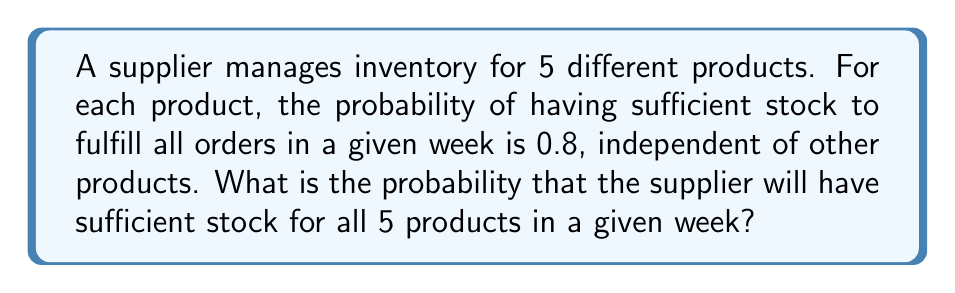Could you help me with this problem? Let's approach this step-by-step:

1) For each product, the probability of having sufficient stock is 0.8.

2) We need to find the probability of having sufficient stock for all 5 products simultaneously.

3) Since the stock sufficiency of each product is independent, we can use the multiplication rule of probability.

4) The probability of all independent events occurring together is the product of their individual probabilities.

5) Let's define the event:
   $A$ = Having sufficient stock for all 5 products

6) Then:
   $$P(A) = 0.8 \times 0.8 \times 0.8 \times 0.8 \times 0.8$$

7) This can be written as:
   $$P(A) = (0.8)^5$$

8) Calculating:
   $$P(A) = (0.8)^5 = 0.32768$$

9) Therefore, the probability of having sufficient stock for all 5 products in a given week is approximately 0.3277 or 32.77%.
Answer: $0.32768$ 